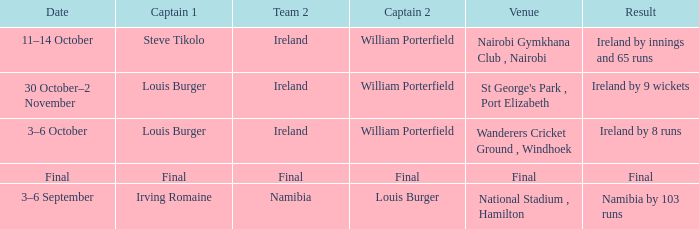Which Captain 2 has a Result of ireland by 8 runs? William Porterfield. 